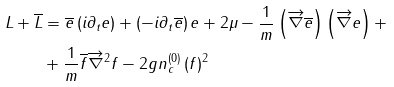<formula> <loc_0><loc_0><loc_500><loc_500>L + \overline { L } & = \overline { e } \left ( i \partial _ { t } e \right ) + \left ( - i \partial _ { t } \overline { e } \right ) e + 2 \mu - \frac { 1 } { m } \left ( \overrightarrow { \nabla } \overline { e } \right ) \left ( \overrightarrow { \nabla } e \right ) + \\ & + \frac { 1 } { m } \overline { f } \overrightarrow { \nabla } ^ { 2 } f - 2 g n _ { c } ^ { \left ( 0 \right ) } \left ( f \right ) ^ { 2 }</formula> 